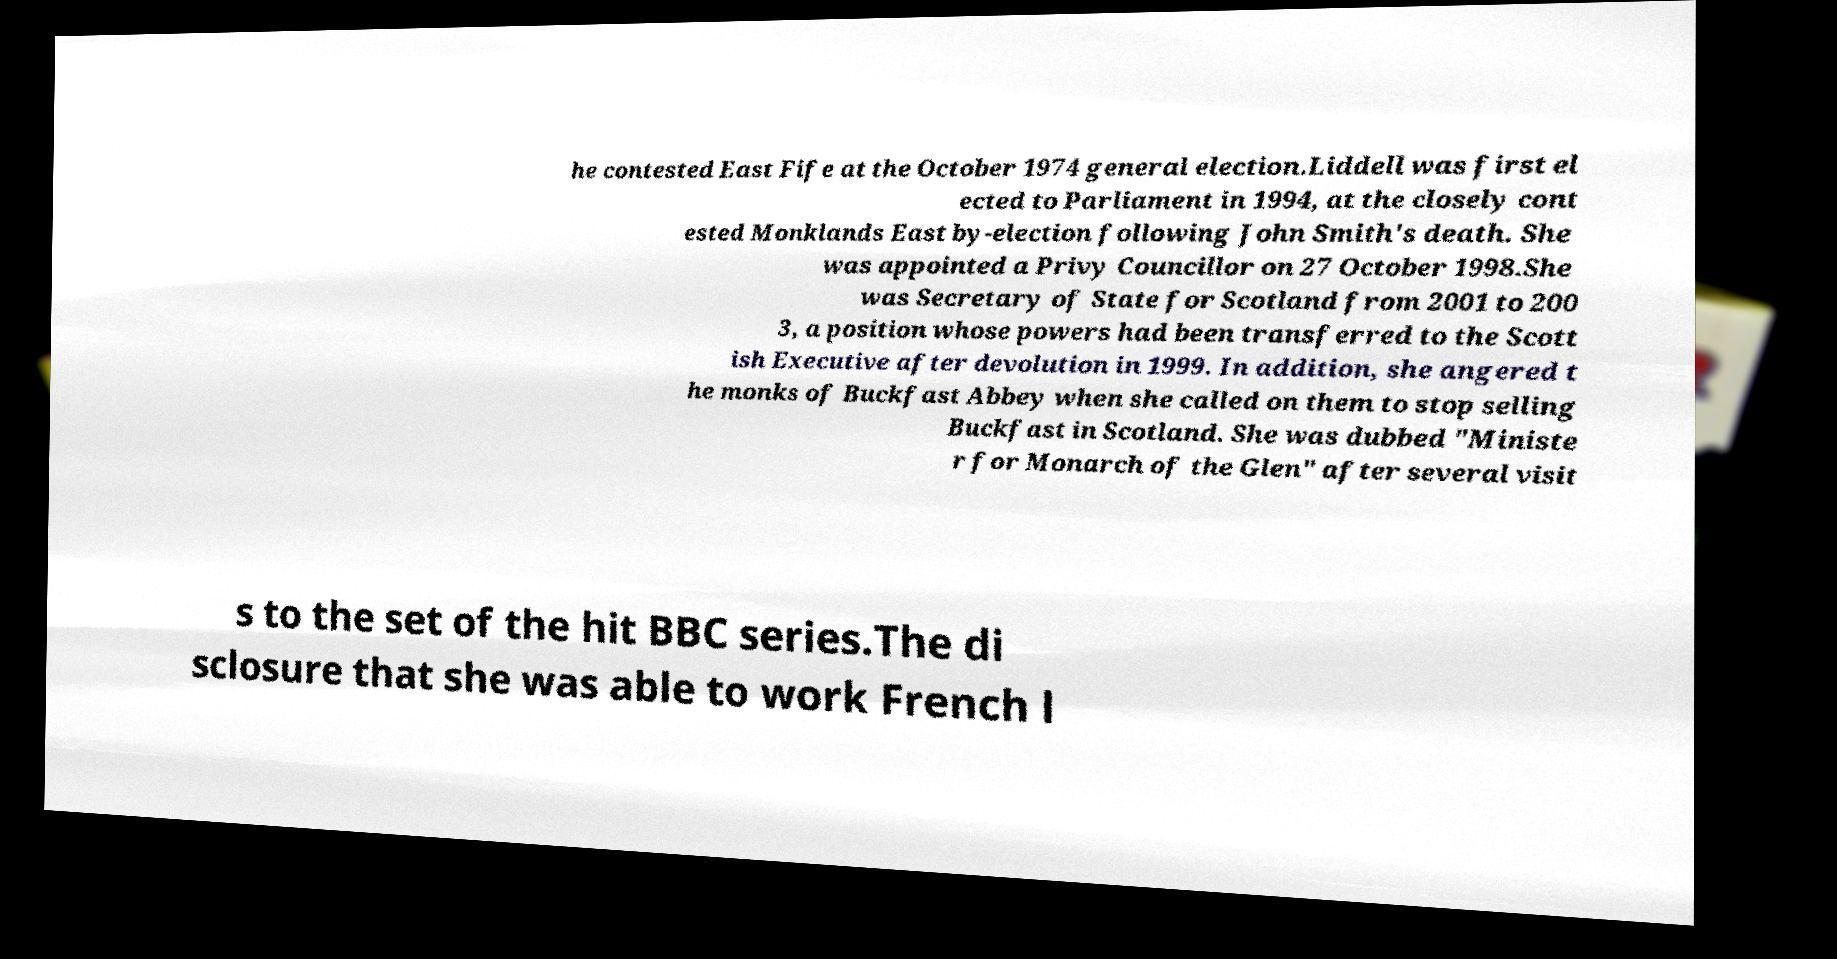I need the written content from this picture converted into text. Can you do that? he contested East Fife at the October 1974 general election.Liddell was first el ected to Parliament in 1994, at the closely cont ested Monklands East by-election following John Smith's death. She was appointed a Privy Councillor on 27 October 1998.She was Secretary of State for Scotland from 2001 to 200 3, a position whose powers had been transferred to the Scott ish Executive after devolution in 1999. In addition, she angered t he monks of Buckfast Abbey when she called on them to stop selling Buckfast in Scotland. She was dubbed "Ministe r for Monarch of the Glen" after several visit s to the set of the hit BBC series.The di sclosure that she was able to work French l 